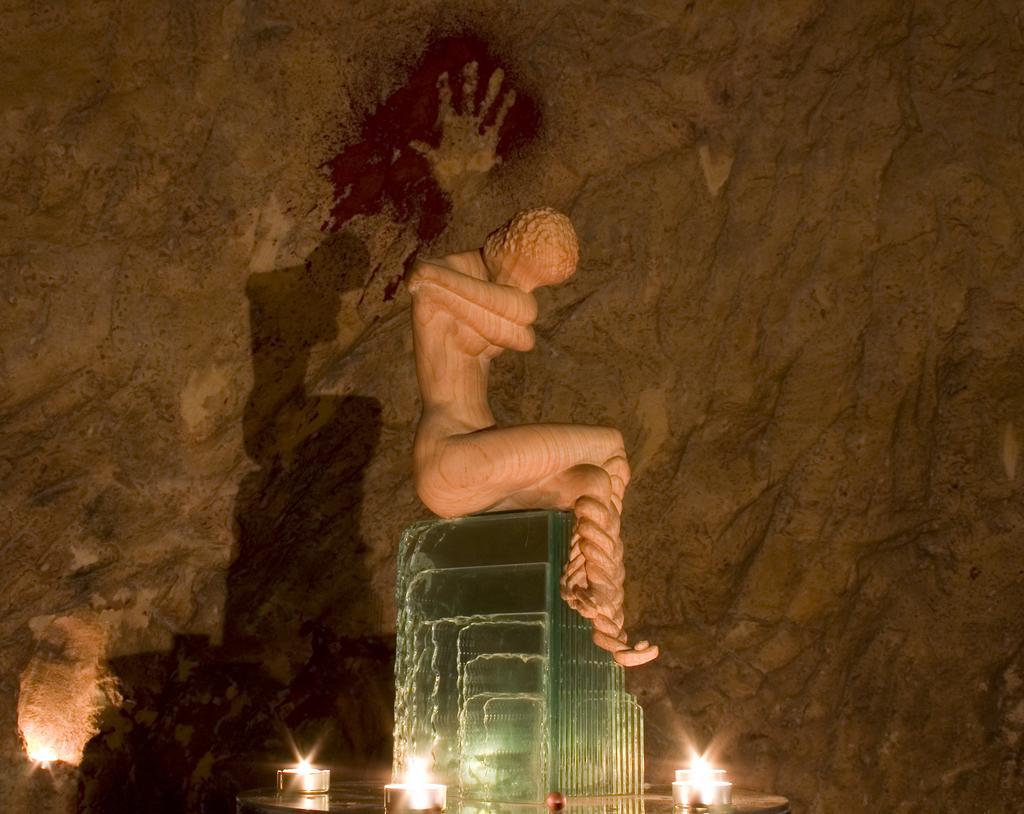Please provide a concise description of this image. In this image I can see statue sitting on a hard object and the background is rocks 